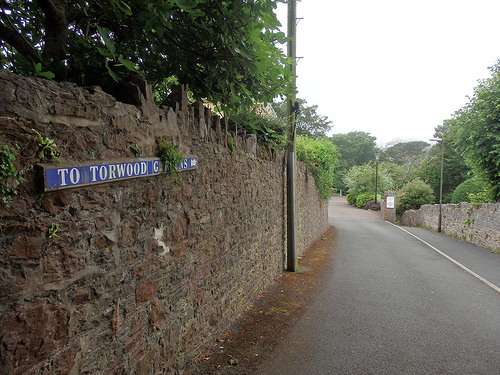<image>
Is there a wall to the left of the road? Yes. From this viewpoint, the wall is positioned to the left side relative to the road. 